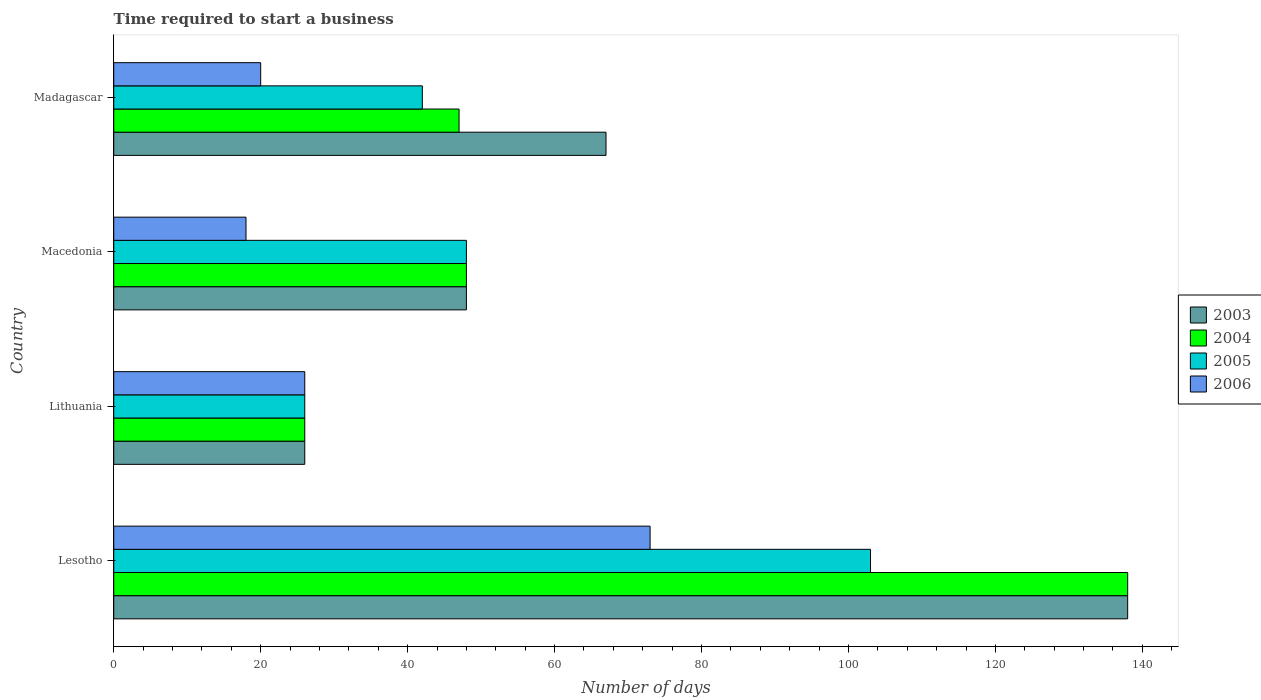How many different coloured bars are there?
Provide a short and direct response. 4. Are the number of bars per tick equal to the number of legend labels?
Provide a succinct answer. Yes. Are the number of bars on each tick of the Y-axis equal?
Provide a succinct answer. Yes. How many bars are there on the 3rd tick from the bottom?
Your answer should be very brief. 4. What is the label of the 3rd group of bars from the top?
Give a very brief answer. Lithuania. In how many cases, is the number of bars for a given country not equal to the number of legend labels?
Keep it short and to the point. 0. What is the number of days required to start a business in 2004 in Lesotho?
Ensure brevity in your answer.  138. Across all countries, what is the maximum number of days required to start a business in 2004?
Keep it short and to the point. 138. In which country was the number of days required to start a business in 2004 maximum?
Offer a very short reply. Lesotho. In which country was the number of days required to start a business in 2005 minimum?
Your response must be concise. Lithuania. What is the total number of days required to start a business in 2005 in the graph?
Provide a short and direct response. 219. What is the difference between the number of days required to start a business in 2006 in Macedonia and that in Madagascar?
Give a very brief answer. -2. What is the difference between the number of days required to start a business in 2005 in Lithuania and the number of days required to start a business in 2006 in Madagascar?
Make the answer very short. 6. What is the average number of days required to start a business in 2004 per country?
Ensure brevity in your answer.  64.75. What is the difference between the number of days required to start a business in 2004 and number of days required to start a business in 2005 in Macedonia?
Make the answer very short. 0. What is the ratio of the number of days required to start a business in 2005 in Lesotho to that in Madagascar?
Give a very brief answer. 2.45. What is the difference between the highest and the lowest number of days required to start a business in 2006?
Give a very brief answer. 55. How many bars are there?
Ensure brevity in your answer.  16. Are the values on the major ticks of X-axis written in scientific E-notation?
Keep it short and to the point. No. Does the graph contain any zero values?
Ensure brevity in your answer.  No. Where does the legend appear in the graph?
Give a very brief answer. Center right. How many legend labels are there?
Your response must be concise. 4. What is the title of the graph?
Make the answer very short. Time required to start a business. Does "1963" appear as one of the legend labels in the graph?
Provide a short and direct response. No. What is the label or title of the X-axis?
Provide a succinct answer. Number of days. What is the label or title of the Y-axis?
Offer a very short reply. Country. What is the Number of days in 2003 in Lesotho?
Offer a very short reply. 138. What is the Number of days of 2004 in Lesotho?
Keep it short and to the point. 138. What is the Number of days of 2005 in Lesotho?
Make the answer very short. 103. What is the Number of days of 2004 in Lithuania?
Your response must be concise. 26. What is the Number of days of 2003 in Macedonia?
Keep it short and to the point. 48. What is the Number of days of 2004 in Macedonia?
Provide a succinct answer. 48. What is the Number of days of 2003 in Madagascar?
Your answer should be compact. 67. What is the Number of days in 2004 in Madagascar?
Your answer should be compact. 47. What is the Number of days of 2005 in Madagascar?
Offer a very short reply. 42. What is the Number of days of 2006 in Madagascar?
Your response must be concise. 20. Across all countries, what is the maximum Number of days in 2003?
Your response must be concise. 138. Across all countries, what is the maximum Number of days in 2004?
Your answer should be very brief. 138. Across all countries, what is the maximum Number of days of 2005?
Your answer should be compact. 103. Across all countries, what is the minimum Number of days in 2003?
Your response must be concise. 26. Across all countries, what is the minimum Number of days in 2004?
Offer a very short reply. 26. Across all countries, what is the minimum Number of days in 2005?
Your answer should be compact. 26. What is the total Number of days of 2003 in the graph?
Ensure brevity in your answer.  279. What is the total Number of days in 2004 in the graph?
Offer a very short reply. 259. What is the total Number of days of 2005 in the graph?
Provide a short and direct response. 219. What is the total Number of days of 2006 in the graph?
Ensure brevity in your answer.  137. What is the difference between the Number of days in 2003 in Lesotho and that in Lithuania?
Your response must be concise. 112. What is the difference between the Number of days in 2004 in Lesotho and that in Lithuania?
Your response must be concise. 112. What is the difference between the Number of days in 2004 in Lesotho and that in Macedonia?
Keep it short and to the point. 90. What is the difference between the Number of days in 2005 in Lesotho and that in Macedonia?
Your response must be concise. 55. What is the difference between the Number of days of 2003 in Lesotho and that in Madagascar?
Your answer should be very brief. 71. What is the difference between the Number of days in 2004 in Lesotho and that in Madagascar?
Offer a very short reply. 91. What is the difference between the Number of days in 2003 in Lithuania and that in Macedonia?
Offer a very short reply. -22. What is the difference between the Number of days of 2004 in Lithuania and that in Macedonia?
Provide a succinct answer. -22. What is the difference between the Number of days of 2005 in Lithuania and that in Macedonia?
Your answer should be very brief. -22. What is the difference between the Number of days of 2006 in Lithuania and that in Macedonia?
Provide a succinct answer. 8. What is the difference between the Number of days of 2003 in Lithuania and that in Madagascar?
Make the answer very short. -41. What is the difference between the Number of days in 2006 in Macedonia and that in Madagascar?
Keep it short and to the point. -2. What is the difference between the Number of days in 2003 in Lesotho and the Number of days in 2004 in Lithuania?
Your answer should be compact. 112. What is the difference between the Number of days of 2003 in Lesotho and the Number of days of 2005 in Lithuania?
Your answer should be very brief. 112. What is the difference between the Number of days of 2003 in Lesotho and the Number of days of 2006 in Lithuania?
Offer a terse response. 112. What is the difference between the Number of days of 2004 in Lesotho and the Number of days of 2005 in Lithuania?
Offer a very short reply. 112. What is the difference between the Number of days of 2004 in Lesotho and the Number of days of 2006 in Lithuania?
Your answer should be compact. 112. What is the difference between the Number of days in 2003 in Lesotho and the Number of days in 2004 in Macedonia?
Keep it short and to the point. 90. What is the difference between the Number of days in 2003 in Lesotho and the Number of days in 2006 in Macedonia?
Your response must be concise. 120. What is the difference between the Number of days in 2004 in Lesotho and the Number of days in 2006 in Macedonia?
Provide a short and direct response. 120. What is the difference between the Number of days in 2003 in Lesotho and the Number of days in 2004 in Madagascar?
Make the answer very short. 91. What is the difference between the Number of days in 2003 in Lesotho and the Number of days in 2005 in Madagascar?
Offer a very short reply. 96. What is the difference between the Number of days of 2003 in Lesotho and the Number of days of 2006 in Madagascar?
Give a very brief answer. 118. What is the difference between the Number of days of 2004 in Lesotho and the Number of days of 2005 in Madagascar?
Provide a succinct answer. 96. What is the difference between the Number of days in 2004 in Lesotho and the Number of days in 2006 in Madagascar?
Keep it short and to the point. 118. What is the difference between the Number of days of 2005 in Lesotho and the Number of days of 2006 in Madagascar?
Ensure brevity in your answer.  83. What is the difference between the Number of days of 2003 in Lithuania and the Number of days of 2005 in Macedonia?
Make the answer very short. -22. What is the difference between the Number of days of 2003 in Lithuania and the Number of days of 2006 in Macedonia?
Your response must be concise. 8. What is the difference between the Number of days of 2004 in Lithuania and the Number of days of 2006 in Macedonia?
Make the answer very short. 8. What is the difference between the Number of days in 2004 in Lithuania and the Number of days in 2005 in Madagascar?
Keep it short and to the point. -16. What is the difference between the Number of days in 2004 in Lithuania and the Number of days in 2006 in Madagascar?
Provide a succinct answer. 6. What is the difference between the Number of days of 2005 in Lithuania and the Number of days of 2006 in Madagascar?
Provide a short and direct response. 6. What is the difference between the Number of days of 2003 in Macedonia and the Number of days of 2004 in Madagascar?
Make the answer very short. 1. What is the difference between the Number of days of 2003 in Macedonia and the Number of days of 2005 in Madagascar?
Offer a very short reply. 6. What is the difference between the Number of days in 2003 in Macedonia and the Number of days in 2006 in Madagascar?
Offer a very short reply. 28. What is the average Number of days in 2003 per country?
Keep it short and to the point. 69.75. What is the average Number of days in 2004 per country?
Give a very brief answer. 64.75. What is the average Number of days in 2005 per country?
Provide a short and direct response. 54.75. What is the average Number of days of 2006 per country?
Your response must be concise. 34.25. What is the difference between the Number of days of 2003 and Number of days of 2005 in Lesotho?
Make the answer very short. 35. What is the difference between the Number of days in 2003 and Number of days in 2006 in Lesotho?
Your answer should be compact. 65. What is the difference between the Number of days in 2004 and Number of days in 2005 in Lesotho?
Provide a short and direct response. 35. What is the difference between the Number of days of 2004 and Number of days of 2006 in Lesotho?
Provide a succinct answer. 65. What is the difference between the Number of days in 2003 and Number of days in 2006 in Lithuania?
Offer a very short reply. 0. What is the difference between the Number of days of 2004 and Number of days of 2006 in Lithuania?
Keep it short and to the point. 0. What is the difference between the Number of days of 2003 and Number of days of 2004 in Macedonia?
Your answer should be very brief. 0. What is the difference between the Number of days of 2003 and Number of days of 2006 in Macedonia?
Your answer should be compact. 30. What is the difference between the Number of days of 2004 and Number of days of 2006 in Macedonia?
Provide a succinct answer. 30. What is the difference between the Number of days in 2005 and Number of days in 2006 in Macedonia?
Provide a succinct answer. 30. What is the difference between the Number of days in 2004 and Number of days in 2005 in Madagascar?
Offer a terse response. 5. What is the difference between the Number of days in 2005 and Number of days in 2006 in Madagascar?
Your response must be concise. 22. What is the ratio of the Number of days of 2003 in Lesotho to that in Lithuania?
Your answer should be very brief. 5.31. What is the ratio of the Number of days in 2004 in Lesotho to that in Lithuania?
Provide a succinct answer. 5.31. What is the ratio of the Number of days of 2005 in Lesotho to that in Lithuania?
Ensure brevity in your answer.  3.96. What is the ratio of the Number of days in 2006 in Lesotho to that in Lithuania?
Make the answer very short. 2.81. What is the ratio of the Number of days in 2003 in Lesotho to that in Macedonia?
Your response must be concise. 2.88. What is the ratio of the Number of days in 2004 in Lesotho to that in Macedonia?
Offer a terse response. 2.88. What is the ratio of the Number of days of 2005 in Lesotho to that in Macedonia?
Offer a terse response. 2.15. What is the ratio of the Number of days of 2006 in Lesotho to that in Macedonia?
Your response must be concise. 4.06. What is the ratio of the Number of days in 2003 in Lesotho to that in Madagascar?
Offer a very short reply. 2.06. What is the ratio of the Number of days in 2004 in Lesotho to that in Madagascar?
Make the answer very short. 2.94. What is the ratio of the Number of days in 2005 in Lesotho to that in Madagascar?
Offer a very short reply. 2.45. What is the ratio of the Number of days of 2006 in Lesotho to that in Madagascar?
Your answer should be compact. 3.65. What is the ratio of the Number of days of 2003 in Lithuania to that in Macedonia?
Offer a very short reply. 0.54. What is the ratio of the Number of days in 2004 in Lithuania to that in Macedonia?
Your response must be concise. 0.54. What is the ratio of the Number of days in 2005 in Lithuania to that in Macedonia?
Make the answer very short. 0.54. What is the ratio of the Number of days in 2006 in Lithuania to that in Macedonia?
Your answer should be very brief. 1.44. What is the ratio of the Number of days in 2003 in Lithuania to that in Madagascar?
Provide a succinct answer. 0.39. What is the ratio of the Number of days of 2004 in Lithuania to that in Madagascar?
Give a very brief answer. 0.55. What is the ratio of the Number of days in 2005 in Lithuania to that in Madagascar?
Make the answer very short. 0.62. What is the ratio of the Number of days in 2003 in Macedonia to that in Madagascar?
Make the answer very short. 0.72. What is the ratio of the Number of days of 2004 in Macedonia to that in Madagascar?
Provide a succinct answer. 1.02. What is the difference between the highest and the second highest Number of days in 2004?
Ensure brevity in your answer.  90. What is the difference between the highest and the second highest Number of days of 2006?
Provide a succinct answer. 47. What is the difference between the highest and the lowest Number of days in 2003?
Your response must be concise. 112. What is the difference between the highest and the lowest Number of days in 2004?
Provide a short and direct response. 112. What is the difference between the highest and the lowest Number of days in 2006?
Your answer should be very brief. 55. 